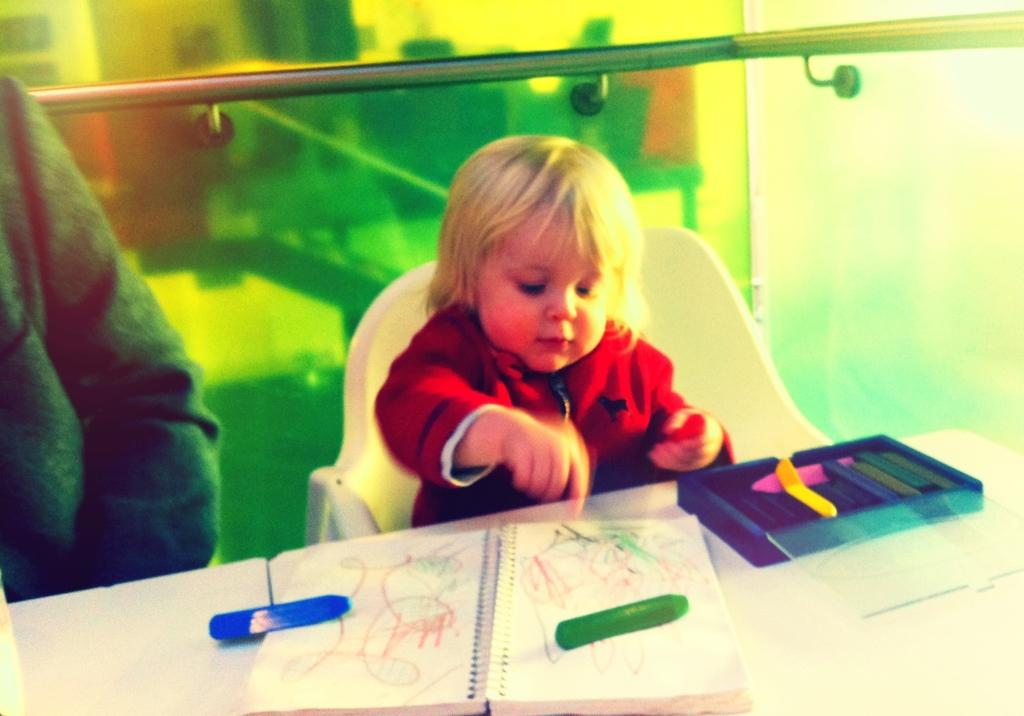What is the main subject of the image? The main subject of the image is a kid. What is the kid doing in the image? The kid is sitting in a chair. Where is the chair located in relation to the table? The chair is in front of a table. What items can be seen on the table? There is a book and crayons on the table. What can be seen in the background of the image? There is a rod and a glass in the background of the image. Can you tell me how many nuts are on the table in the image? There are no nuts present on the table in the image. Is there a squirrel visible in the image? There is no squirrel present in the image. 